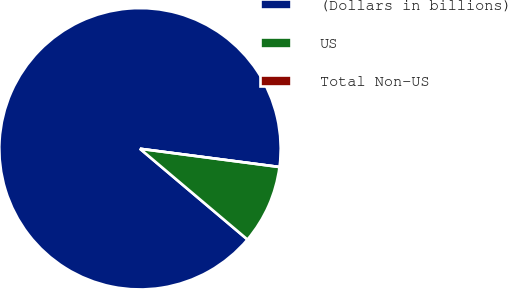Convert chart. <chart><loc_0><loc_0><loc_500><loc_500><pie_chart><fcel>(Dollars in billions)<fcel>US<fcel>Total Non-US<nl><fcel>90.91%<fcel>9.09%<fcel>0.0%<nl></chart> 